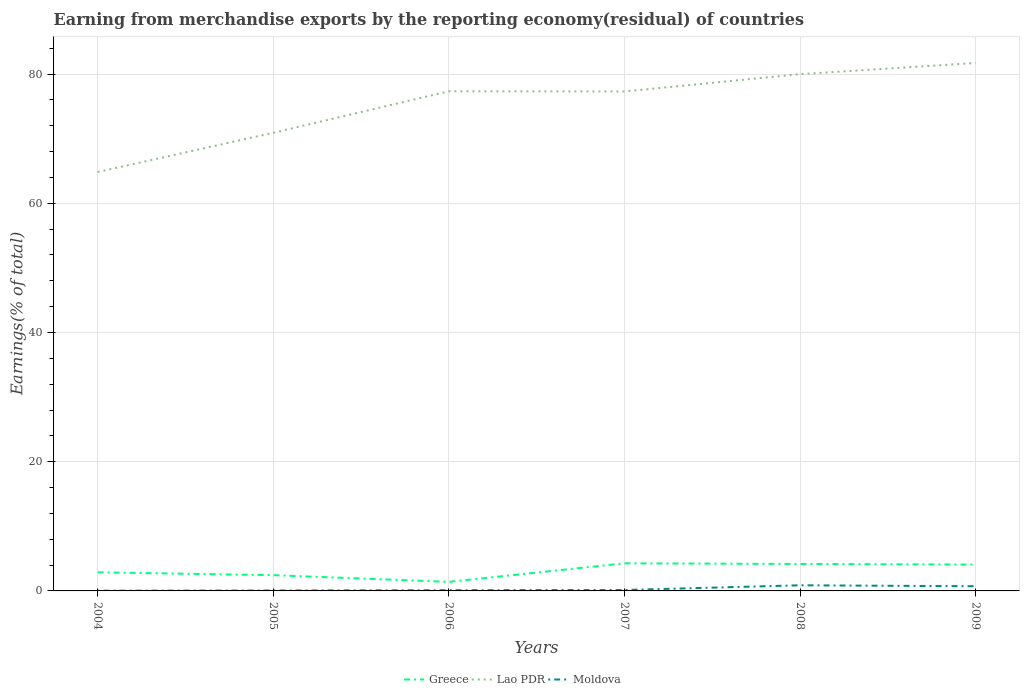Does the line corresponding to Moldova intersect with the line corresponding to Greece?
Your answer should be compact. No. Across all years, what is the maximum percentage of amount earned from merchandise exports in Lao PDR?
Make the answer very short. 64.84. What is the total percentage of amount earned from merchandise exports in Greece in the graph?
Keep it short and to the point. -1.73. What is the difference between the highest and the second highest percentage of amount earned from merchandise exports in Moldova?
Offer a terse response. 0.84. How many lines are there?
Your response must be concise. 3. How many years are there in the graph?
Ensure brevity in your answer.  6. Are the values on the major ticks of Y-axis written in scientific E-notation?
Make the answer very short. No. Does the graph contain grids?
Offer a terse response. Yes. How many legend labels are there?
Provide a short and direct response. 3. What is the title of the graph?
Offer a terse response. Earning from merchandise exports by the reporting economy(residual) of countries. Does "Equatorial Guinea" appear as one of the legend labels in the graph?
Your response must be concise. No. What is the label or title of the Y-axis?
Provide a succinct answer. Earnings(% of total). What is the Earnings(% of total) of Greece in 2004?
Keep it short and to the point. 2.88. What is the Earnings(% of total) of Lao PDR in 2004?
Your response must be concise. 64.84. What is the Earnings(% of total) of Moldova in 2004?
Keep it short and to the point. 0.04. What is the Earnings(% of total) of Greece in 2005?
Make the answer very short. 2.44. What is the Earnings(% of total) of Lao PDR in 2005?
Your response must be concise. 70.91. What is the Earnings(% of total) in Moldova in 2005?
Provide a succinct answer. 0.06. What is the Earnings(% of total) in Greece in 2006?
Give a very brief answer. 1.4. What is the Earnings(% of total) of Lao PDR in 2006?
Provide a short and direct response. 77.34. What is the Earnings(% of total) in Moldova in 2006?
Ensure brevity in your answer.  0.12. What is the Earnings(% of total) of Greece in 2007?
Provide a short and direct response. 4.27. What is the Earnings(% of total) in Lao PDR in 2007?
Offer a very short reply. 77.31. What is the Earnings(% of total) in Moldova in 2007?
Ensure brevity in your answer.  0.14. What is the Earnings(% of total) of Greece in 2008?
Make the answer very short. 4.17. What is the Earnings(% of total) in Lao PDR in 2008?
Make the answer very short. 79.99. What is the Earnings(% of total) of Moldova in 2008?
Provide a succinct answer. 0.87. What is the Earnings(% of total) in Greece in 2009?
Provide a short and direct response. 4.08. What is the Earnings(% of total) of Lao PDR in 2009?
Ensure brevity in your answer.  81.72. What is the Earnings(% of total) of Moldova in 2009?
Give a very brief answer. 0.73. Across all years, what is the maximum Earnings(% of total) of Greece?
Give a very brief answer. 4.27. Across all years, what is the maximum Earnings(% of total) of Lao PDR?
Your answer should be very brief. 81.72. Across all years, what is the maximum Earnings(% of total) of Moldova?
Offer a terse response. 0.87. Across all years, what is the minimum Earnings(% of total) in Greece?
Offer a very short reply. 1.4. Across all years, what is the minimum Earnings(% of total) of Lao PDR?
Make the answer very short. 64.84. Across all years, what is the minimum Earnings(% of total) in Moldova?
Your answer should be compact. 0.04. What is the total Earnings(% of total) of Greece in the graph?
Your answer should be very brief. 19.24. What is the total Earnings(% of total) of Lao PDR in the graph?
Provide a succinct answer. 452.1. What is the total Earnings(% of total) of Moldova in the graph?
Keep it short and to the point. 1.96. What is the difference between the Earnings(% of total) in Greece in 2004 and that in 2005?
Offer a very short reply. 0.44. What is the difference between the Earnings(% of total) of Lao PDR in 2004 and that in 2005?
Offer a very short reply. -6.07. What is the difference between the Earnings(% of total) of Moldova in 2004 and that in 2005?
Provide a short and direct response. -0.03. What is the difference between the Earnings(% of total) in Greece in 2004 and that in 2006?
Your answer should be very brief. 1.48. What is the difference between the Earnings(% of total) of Lao PDR in 2004 and that in 2006?
Provide a succinct answer. -12.5. What is the difference between the Earnings(% of total) in Moldova in 2004 and that in 2006?
Keep it short and to the point. -0.08. What is the difference between the Earnings(% of total) in Greece in 2004 and that in 2007?
Make the answer very short. -1.39. What is the difference between the Earnings(% of total) of Lao PDR in 2004 and that in 2007?
Make the answer very short. -12.47. What is the difference between the Earnings(% of total) of Moldova in 2004 and that in 2007?
Offer a terse response. -0.11. What is the difference between the Earnings(% of total) of Greece in 2004 and that in 2008?
Provide a succinct answer. -1.29. What is the difference between the Earnings(% of total) in Lao PDR in 2004 and that in 2008?
Give a very brief answer. -15.15. What is the difference between the Earnings(% of total) of Moldova in 2004 and that in 2008?
Your answer should be very brief. -0.84. What is the difference between the Earnings(% of total) of Greece in 2004 and that in 2009?
Ensure brevity in your answer.  -1.19. What is the difference between the Earnings(% of total) of Lao PDR in 2004 and that in 2009?
Give a very brief answer. -16.88. What is the difference between the Earnings(% of total) of Moldova in 2004 and that in 2009?
Make the answer very short. -0.69. What is the difference between the Earnings(% of total) of Greece in 2005 and that in 2006?
Ensure brevity in your answer.  1.04. What is the difference between the Earnings(% of total) of Lao PDR in 2005 and that in 2006?
Your answer should be very brief. -6.43. What is the difference between the Earnings(% of total) of Moldova in 2005 and that in 2006?
Give a very brief answer. -0.05. What is the difference between the Earnings(% of total) of Greece in 2005 and that in 2007?
Make the answer very short. -1.83. What is the difference between the Earnings(% of total) of Lao PDR in 2005 and that in 2007?
Give a very brief answer. -6.4. What is the difference between the Earnings(% of total) of Moldova in 2005 and that in 2007?
Your response must be concise. -0.08. What is the difference between the Earnings(% of total) in Greece in 2005 and that in 2008?
Ensure brevity in your answer.  -1.73. What is the difference between the Earnings(% of total) of Lao PDR in 2005 and that in 2008?
Make the answer very short. -9.08. What is the difference between the Earnings(% of total) in Moldova in 2005 and that in 2008?
Your answer should be very brief. -0.81. What is the difference between the Earnings(% of total) of Greece in 2005 and that in 2009?
Make the answer very short. -1.64. What is the difference between the Earnings(% of total) of Lao PDR in 2005 and that in 2009?
Offer a terse response. -10.81. What is the difference between the Earnings(% of total) of Moldova in 2005 and that in 2009?
Your answer should be very brief. -0.66. What is the difference between the Earnings(% of total) in Greece in 2006 and that in 2007?
Offer a terse response. -2.87. What is the difference between the Earnings(% of total) of Lao PDR in 2006 and that in 2007?
Give a very brief answer. 0.03. What is the difference between the Earnings(% of total) in Moldova in 2006 and that in 2007?
Your answer should be compact. -0.03. What is the difference between the Earnings(% of total) of Greece in 2006 and that in 2008?
Your answer should be compact. -2.77. What is the difference between the Earnings(% of total) in Lao PDR in 2006 and that in 2008?
Offer a very short reply. -2.65. What is the difference between the Earnings(% of total) in Moldova in 2006 and that in 2008?
Keep it short and to the point. -0.76. What is the difference between the Earnings(% of total) in Greece in 2006 and that in 2009?
Give a very brief answer. -2.67. What is the difference between the Earnings(% of total) of Lao PDR in 2006 and that in 2009?
Provide a short and direct response. -4.38. What is the difference between the Earnings(% of total) in Moldova in 2006 and that in 2009?
Keep it short and to the point. -0.61. What is the difference between the Earnings(% of total) of Greece in 2007 and that in 2008?
Offer a terse response. 0.1. What is the difference between the Earnings(% of total) in Lao PDR in 2007 and that in 2008?
Give a very brief answer. -2.68. What is the difference between the Earnings(% of total) in Moldova in 2007 and that in 2008?
Give a very brief answer. -0.73. What is the difference between the Earnings(% of total) in Greece in 2007 and that in 2009?
Keep it short and to the point. 0.2. What is the difference between the Earnings(% of total) in Lao PDR in 2007 and that in 2009?
Provide a succinct answer. -4.41. What is the difference between the Earnings(% of total) in Moldova in 2007 and that in 2009?
Make the answer very short. -0.58. What is the difference between the Earnings(% of total) of Greece in 2008 and that in 2009?
Make the answer very short. 0.1. What is the difference between the Earnings(% of total) of Lao PDR in 2008 and that in 2009?
Offer a terse response. -1.73. What is the difference between the Earnings(% of total) of Moldova in 2008 and that in 2009?
Ensure brevity in your answer.  0.15. What is the difference between the Earnings(% of total) in Greece in 2004 and the Earnings(% of total) in Lao PDR in 2005?
Offer a very short reply. -68.03. What is the difference between the Earnings(% of total) of Greece in 2004 and the Earnings(% of total) of Moldova in 2005?
Your answer should be very brief. 2.82. What is the difference between the Earnings(% of total) of Lao PDR in 2004 and the Earnings(% of total) of Moldova in 2005?
Your answer should be very brief. 64.77. What is the difference between the Earnings(% of total) of Greece in 2004 and the Earnings(% of total) of Lao PDR in 2006?
Give a very brief answer. -74.46. What is the difference between the Earnings(% of total) of Greece in 2004 and the Earnings(% of total) of Moldova in 2006?
Offer a very short reply. 2.76. What is the difference between the Earnings(% of total) of Lao PDR in 2004 and the Earnings(% of total) of Moldova in 2006?
Your answer should be very brief. 64.72. What is the difference between the Earnings(% of total) in Greece in 2004 and the Earnings(% of total) in Lao PDR in 2007?
Keep it short and to the point. -74.43. What is the difference between the Earnings(% of total) in Greece in 2004 and the Earnings(% of total) in Moldova in 2007?
Ensure brevity in your answer.  2.74. What is the difference between the Earnings(% of total) in Lao PDR in 2004 and the Earnings(% of total) in Moldova in 2007?
Provide a short and direct response. 64.69. What is the difference between the Earnings(% of total) in Greece in 2004 and the Earnings(% of total) in Lao PDR in 2008?
Offer a very short reply. -77.11. What is the difference between the Earnings(% of total) of Greece in 2004 and the Earnings(% of total) of Moldova in 2008?
Keep it short and to the point. 2.01. What is the difference between the Earnings(% of total) of Lao PDR in 2004 and the Earnings(% of total) of Moldova in 2008?
Make the answer very short. 63.96. What is the difference between the Earnings(% of total) in Greece in 2004 and the Earnings(% of total) in Lao PDR in 2009?
Give a very brief answer. -78.84. What is the difference between the Earnings(% of total) of Greece in 2004 and the Earnings(% of total) of Moldova in 2009?
Give a very brief answer. 2.16. What is the difference between the Earnings(% of total) in Lao PDR in 2004 and the Earnings(% of total) in Moldova in 2009?
Offer a terse response. 64.11. What is the difference between the Earnings(% of total) in Greece in 2005 and the Earnings(% of total) in Lao PDR in 2006?
Provide a succinct answer. -74.9. What is the difference between the Earnings(% of total) in Greece in 2005 and the Earnings(% of total) in Moldova in 2006?
Ensure brevity in your answer.  2.32. What is the difference between the Earnings(% of total) in Lao PDR in 2005 and the Earnings(% of total) in Moldova in 2006?
Keep it short and to the point. 70.79. What is the difference between the Earnings(% of total) of Greece in 2005 and the Earnings(% of total) of Lao PDR in 2007?
Keep it short and to the point. -74.87. What is the difference between the Earnings(% of total) of Greece in 2005 and the Earnings(% of total) of Moldova in 2007?
Offer a very short reply. 2.3. What is the difference between the Earnings(% of total) of Lao PDR in 2005 and the Earnings(% of total) of Moldova in 2007?
Ensure brevity in your answer.  70.77. What is the difference between the Earnings(% of total) of Greece in 2005 and the Earnings(% of total) of Lao PDR in 2008?
Keep it short and to the point. -77.55. What is the difference between the Earnings(% of total) of Greece in 2005 and the Earnings(% of total) of Moldova in 2008?
Keep it short and to the point. 1.57. What is the difference between the Earnings(% of total) in Lao PDR in 2005 and the Earnings(% of total) in Moldova in 2008?
Your answer should be very brief. 70.04. What is the difference between the Earnings(% of total) of Greece in 2005 and the Earnings(% of total) of Lao PDR in 2009?
Offer a terse response. -79.28. What is the difference between the Earnings(% of total) in Greece in 2005 and the Earnings(% of total) in Moldova in 2009?
Your response must be concise. 1.71. What is the difference between the Earnings(% of total) of Lao PDR in 2005 and the Earnings(% of total) of Moldova in 2009?
Keep it short and to the point. 70.18. What is the difference between the Earnings(% of total) in Greece in 2006 and the Earnings(% of total) in Lao PDR in 2007?
Make the answer very short. -75.91. What is the difference between the Earnings(% of total) of Greece in 2006 and the Earnings(% of total) of Moldova in 2007?
Your response must be concise. 1.26. What is the difference between the Earnings(% of total) in Lao PDR in 2006 and the Earnings(% of total) in Moldova in 2007?
Make the answer very short. 77.19. What is the difference between the Earnings(% of total) of Greece in 2006 and the Earnings(% of total) of Lao PDR in 2008?
Your response must be concise. -78.59. What is the difference between the Earnings(% of total) in Greece in 2006 and the Earnings(% of total) in Moldova in 2008?
Give a very brief answer. 0.53. What is the difference between the Earnings(% of total) in Lao PDR in 2006 and the Earnings(% of total) in Moldova in 2008?
Offer a very short reply. 76.47. What is the difference between the Earnings(% of total) in Greece in 2006 and the Earnings(% of total) in Lao PDR in 2009?
Offer a very short reply. -80.32. What is the difference between the Earnings(% of total) of Greece in 2006 and the Earnings(% of total) of Moldova in 2009?
Give a very brief answer. 0.68. What is the difference between the Earnings(% of total) of Lao PDR in 2006 and the Earnings(% of total) of Moldova in 2009?
Ensure brevity in your answer.  76.61. What is the difference between the Earnings(% of total) in Greece in 2007 and the Earnings(% of total) in Lao PDR in 2008?
Your answer should be very brief. -75.72. What is the difference between the Earnings(% of total) of Greece in 2007 and the Earnings(% of total) of Moldova in 2008?
Your answer should be compact. 3.4. What is the difference between the Earnings(% of total) of Lao PDR in 2007 and the Earnings(% of total) of Moldova in 2008?
Offer a very short reply. 76.44. What is the difference between the Earnings(% of total) in Greece in 2007 and the Earnings(% of total) in Lao PDR in 2009?
Keep it short and to the point. -77.45. What is the difference between the Earnings(% of total) in Greece in 2007 and the Earnings(% of total) in Moldova in 2009?
Give a very brief answer. 3.55. What is the difference between the Earnings(% of total) of Lao PDR in 2007 and the Earnings(% of total) of Moldova in 2009?
Give a very brief answer. 76.58. What is the difference between the Earnings(% of total) of Greece in 2008 and the Earnings(% of total) of Lao PDR in 2009?
Your response must be concise. -77.55. What is the difference between the Earnings(% of total) in Greece in 2008 and the Earnings(% of total) in Moldova in 2009?
Give a very brief answer. 3.45. What is the difference between the Earnings(% of total) of Lao PDR in 2008 and the Earnings(% of total) of Moldova in 2009?
Give a very brief answer. 79.26. What is the average Earnings(% of total) of Greece per year?
Your response must be concise. 3.21. What is the average Earnings(% of total) of Lao PDR per year?
Provide a short and direct response. 75.35. What is the average Earnings(% of total) in Moldova per year?
Offer a terse response. 0.33. In the year 2004, what is the difference between the Earnings(% of total) of Greece and Earnings(% of total) of Lao PDR?
Ensure brevity in your answer.  -61.96. In the year 2004, what is the difference between the Earnings(% of total) in Greece and Earnings(% of total) in Moldova?
Your answer should be compact. 2.84. In the year 2004, what is the difference between the Earnings(% of total) of Lao PDR and Earnings(% of total) of Moldova?
Offer a terse response. 64.8. In the year 2005, what is the difference between the Earnings(% of total) in Greece and Earnings(% of total) in Lao PDR?
Your answer should be very brief. -68.47. In the year 2005, what is the difference between the Earnings(% of total) in Greece and Earnings(% of total) in Moldova?
Your answer should be compact. 2.37. In the year 2005, what is the difference between the Earnings(% of total) of Lao PDR and Earnings(% of total) of Moldova?
Your answer should be very brief. 70.84. In the year 2006, what is the difference between the Earnings(% of total) in Greece and Earnings(% of total) in Lao PDR?
Keep it short and to the point. -75.94. In the year 2006, what is the difference between the Earnings(% of total) in Greece and Earnings(% of total) in Moldova?
Keep it short and to the point. 1.29. In the year 2006, what is the difference between the Earnings(% of total) in Lao PDR and Earnings(% of total) in Moldova?
Your response must be concise. 77.22. In the year 2007, what is the difference between the Earnings(% of total) of Greece and Earnings(% of total) of Lao PDR?
Provide a succinct answer. -73.04. In the year 2007, what is the difference between the Earnings(% of total) in Greece and Earnings(% of total) in Moldova?
Offer a very short reply. 4.13. In the year 2007, what is the difference between the Earnings(% of total) of Lao PDR and Earnings(% of total) of Moldova?
Offer a very short reply. 77.16. In the year 2008, what is the difference between the Earnings(% of total) in Greece and Earnings(% of total) in Lao PDR?
Provide a succinct answer. -75.82. In the year 2008, what is the difference between the Earnings(% of total) of Greece and Earnings(% of total) of Moldova?
Your answer should be very brief. 3.3. In the year 2008, what is the difference between the Earnings(% of total) in Lao PDR and Earnings(% of total) in Moldova?
Ensure brevity in your answer.  79.12. In the year 2009, what is the difference between the Earnings(% of total) of Greece and Earnings(% of total) of Lao PDR?
Provide a short and direct response. -77.65. In the year 2009, what is the difference between the Earnings(% of total) of Greece and Earnings(% of total) of Moldova?
Make the answer very short. 3.35. In the year 2009, what is the difference between the Earnings(% of total) of Lao PDR and Earnings(% of total) of Moldova?
Ensure brevity in your answer.  81. What is the ratio of the Earnings(% of total) of Greece in 2004 to that in 2005?
Provide a succinct answer. 1.18. What is the ratio of the Earnings(% of total) in Lao PDR in 2004 to that in 2005?
Your answer should be compact. 0.91. What is the ratio of the Earnings(% of total) in Moldova in 2004 to that in 2005?
Make the answer very short. 0.57. What is the ratio of the Earnings(% of total) of Greece in 2004 to that in 2006?
Your answer should be very brief. 2.06. What is the ratio of the Earnings(% of total) of Lao PDR in 2004 to that in 2006?
Your response must be concise. 0.84. What is the ratio of the Earnings(% of total) of Moldova in 2004 to that in 2006?
Provide a succinct answer. 0.32. What is the ratio of the Earnings(% of total) in Greece in 2004 to that in 2007?
Make the answer very short. 0.67. What is the ratio of the Earnings(% of total) in Lao PDR in 2004 to that in 2007?
Make the answer very short. 0.84. What is the ratio of the Earnings(% of total) of Moldova in 2004 to that in 2007?
Make the answer very short. 0.26. What is the ratio of the Earnings(% of total) in Greece in 2004 to that in 2008?
Offer a very short reply. 0.69. What is the ratio of the Earnings(% of total) of Lao PDR in 2004 to that in 2008?
Offer a very short reply. 0.81. What is the ratio of the Earnings(% of total) in Moldova in 2004 to that in 2008?
Ensure brevity in your answer.  0.04. What is the ratio of the Earnings(% of total) in Greece in 2004 to that in 2009?
Offer a very short reply. 0.71. What is the ratio of the Earnings(% of total) in Lao PDR in 2004 to that in 2009?
Your answer should be very brief. 0.79. What is the ratio of the Earnings(% of total) in Moldova in 2004 to that in 2009?
Your answer should be compact. 0.05. What is the ratio of the Earnings(% of total) in Greece in 2005 to that in 2006?
Offer a very short reply. 1.74. What is the ratio of the Earnings(% of total) of Lao PDR in 2005 to that in 2006?
Make the answer very short. 0.92. What is the ratio of the Earnings(% of total) in Moldova in 2005 to that in 2006?
Make the answer very short. 0.56. What is the ratio of the Earnings(% of total) of Greece in 2005 to that in 2007?
Ensure brevity in your answer.  0.57. What is the ratio of the Earnings(% of total) in Lao PDR in 2005 to that in 2007?
Offer a very short reply. 0.92. What is the ratio of the Earnings(% of total) in Moldova in 2005 to that in 2007?
Provide a short and direct response. 0.45. What is the ratio of the Earnings(% of total) of Greece in 2005 to that in 2008?
Make the answer very short. 0.58. What is the ratio of the Earnings(% of total) in Lao PDR in 2005 to that in 2008?
Offer a very short reply. 0.89. What is the ratio of the Earnings(% of total) of Moldova in 2005 to that in 2008?
Offer a terse response. 0.07. What is the ratio of the Earnings(% of total) in Greece in 2005 to that in 2009?
Ensure brevity in your answer.  0.6. What is the ratio of the Earnings(% of total) in Lao PDR in 2005 to that in 2009?
Ensure brevity in your answer.  0.87. What is the ratio of the Earnings(% of total) in Moldova in 2005 to that in 2009?
Keep it short and to the point. 0.09. What is the ratio of the Earnings(% of total) of Greece in 2006 to that in 2007?
Your response must be concise. 0.33. What is the ratio of the Earnings(% of total) in Moldova in 2006 to that in 2007?
Keep it short and to the point. 0.81. What is the ratio of the Earnings(% of total) in Greece in 2006 to that in 2008?
Offer a terse response. 0.34. What is the ratio of the Earnings(% of total) in Lao PDR in 2006 to that in 2008?
Provide a succinct answer. 0.97. What is the ratio of the Earnings(% of total) of Moldova in 2006 to that in 2008?
Your response must be concise. 0.13. What is the ratio of the Earnings(% of total) of Greece in 2006 to that in 2009?
Provide a short and direct response. 0.34. What is the ratio of the Earnings(% of total) in Lao PDR in 2006 to that in 2009?
Your answer should be compact. 0.95. What is the ratio of the Earnings(% of total) of Moldova in 2006 to that in 2009?
Offer a very short reply. 0.16. What is the ratio of the Earnings(% of total) in Greece in 2007 to that in 2008?
Your answer should be compact. 1.02. What is the ratio of the Earnings(% of total) in Lao PDR in 2007 to that in 2008?
Keep it short and to the point. 0.97. What is the ratio of the Earnings(% of total) in Moldova in 2007 to that in 2008?
Give a very brief answer. 0.17. What is the ratio of the Earnings(% of total) of Greece in 2007 to that in 2009?
Keep it short and to the point. 1.05. What is the ratio of the Earnings(% of total) of Lao PDR in 2007 to that in 2009?
Provide a succinct answer. 0.95. What is the ratio of the Earnings(% of total) of Moldova in 2007 to that in 2009?
Provide a succinct answer. 0.2. What is the ratio of the Earnings(% of total) in Greece in 2008 to that in 2009?
Make the answer very short. 1.02. What is the ratio of the Earnings(% of total) of Lao PDR in 2008 to that in 2009?
Your answer should be compact. 0.98. What is the ratio of the Earnings(% of total) in Moldova in 2008 to that in 2009?
Provide a short and direct response. 1.2. What is the difference between the highest and the second highest Earnings(% of total) of Greece?
Your answer should be very brief. 0.1. What is the difference between the highest and the second highest Earnings(% of total) in Lao PDR?
Offer a very short reply. 1.73. What is the difference between the highest and the second highest Earnings(% of total) of Moldova?
Offer a very short reply. 0.15. What is the difference between the highest and the lowest Earnings(% of total) in Greece?
Provide a succinct answer. 2.87. What is the difference between the highest and the lowest Earnings(% of total) in Lao PDR?
Keep it short and to the point. 16.88. What is the difference between the highest and the lowest Earnings(% of total) of Moldova?
Provide a short and direct response. 0.84. 